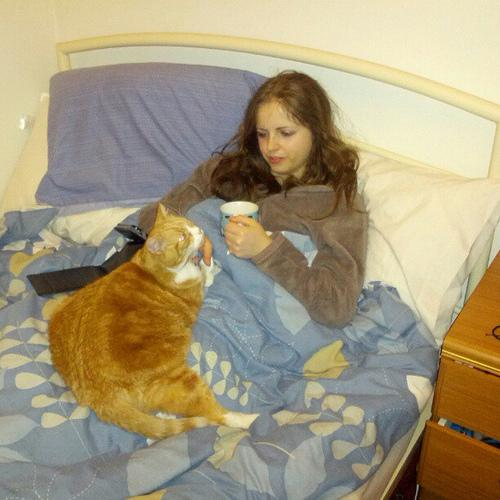What type of furniture is near the bed, and what notable feature does it have? There is a wooden nightstand next to the bed, and it has a slightly opened drawer. Can you describe the position and size of the headboard in relation to the bed? The white and cream headboard is positioned at the top of the bed and measures 457 in width and height. Give a brief overview of the scene in the image. A sick woman wearing a gray sweater is laying in bed, covered with a blue comforter, holding a cup, and surrounded by various pillows with a fat orange cat resting on the bed. Identify and describe any object the woman interacts with in the image. The lady is holding a coffee mug in her hand and laying on a pillow. What are the characteristics of the cat in the image? The cat is fat, orange or brown, and laying down on the bed. How many different pillows are on the bed, and what are their colors? There are four different pillows: a large blue pillow, a large white pillow, a blue pillow on the bed, and an off-white pillow underneath the lady. Are there any common color schemes in the bedroom, such as the walls and bedsheet? The bedroom walls and bedsheet are both white. How would you describe the woman's demeanor in the image? The woman appears to be sick and resting in bed. What is the color and pattern/design on the comforter? The comforter is blue with a white design. What can you infer about the woman's condition based on her appearance and surroundings? The woman is likely unwell, as she is laying in bed with a cup in her hand, wearing a sweater, and surrounded by various pillows for comfort. 